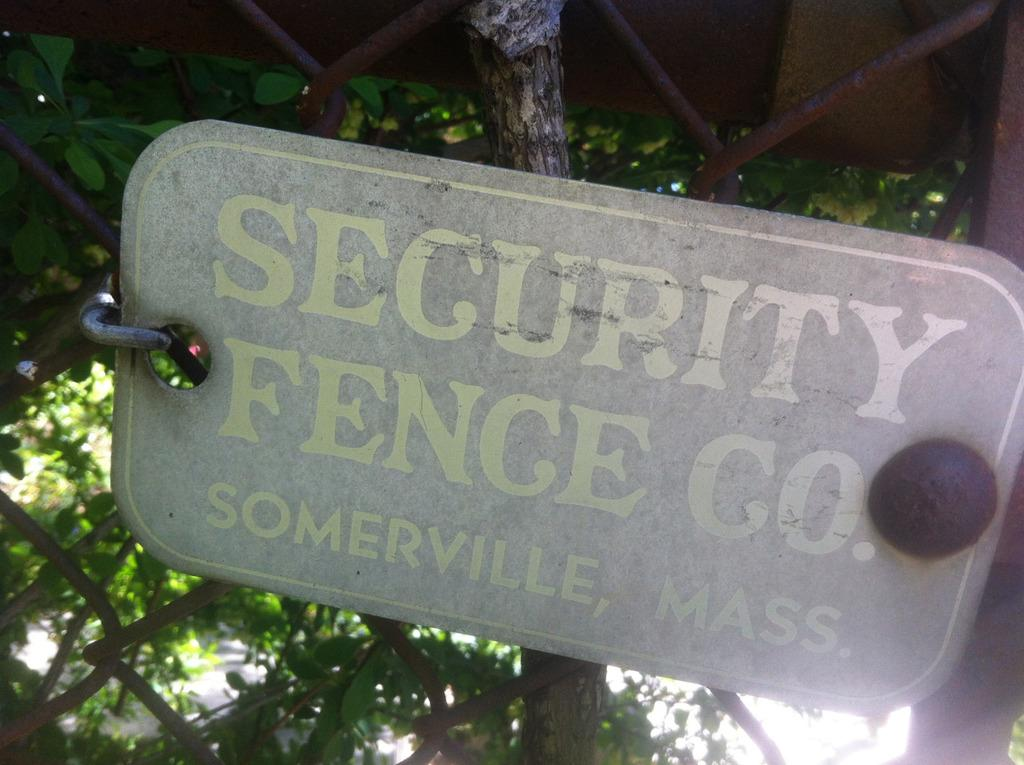What is on the board that is visible in the image? There are words written on the board in the image. What type of structure can be seen in the image? There is fencing in the image. What can be seen in the background of the image? There are trees in the background of the image. What position does the donkey hold in the organization depicted in the image? There is no donkey or organization present in the image. 